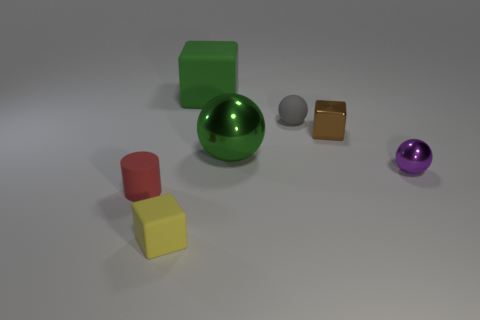Add 2 small rubber cylinders. How many objects exist? 9 Subtract all cylinders. How many objects are left? 6 Subtract all yellow rubber objects. Subtract all metallic blocks. How many objects are left? 5 Add 6 tiny purple things. How many tiny purple things are left? 7 Add 5 large blocks. How many large blocks exist? 6 Subtract 1 red cylinders. How many objects are left? 6 